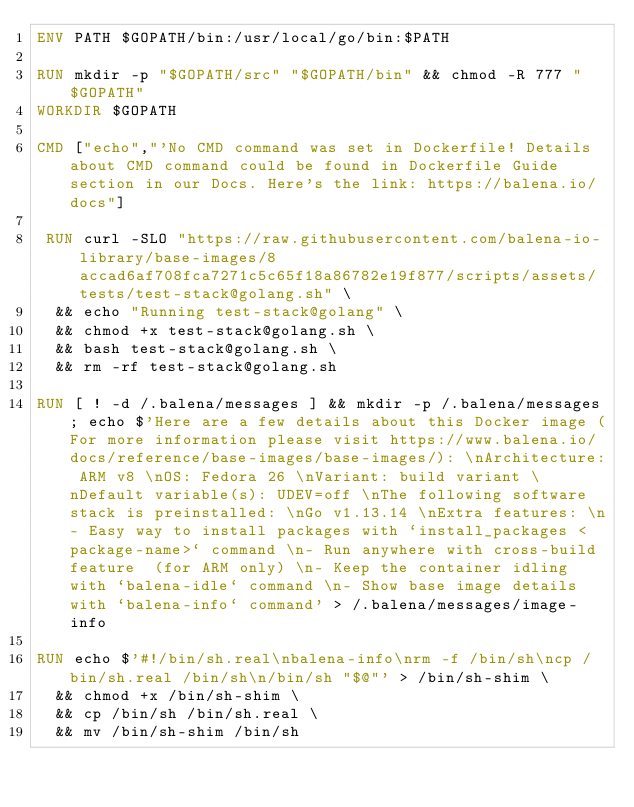Convert code to text. <code><loc_0><loc_0><loc_500><loc_500><_Dockerfile_>ENV PATH $GOPATH/bin:/usr/local/go/bin:$PATH

RUN mkdir -p "$GOPATH/src" "$GOPATH/bin" && chmod -R 777 "$GOPATH"
WORKDIR $GOPATH

CMD ["echo","'No CMD command was set in Dockerfile! Details about CMD command could be found in Dockerfile Guide section in our Docs. Here's the link: https://balena.io/docs"]

 RUN curl -SLO "https://raw.githubusercontent.com/balena-io-library/base-images/8accad6af708fca7271c5c65f18a86782e19f877/scripts/assets/tests/test-stack@golang.sh" \
  && echo "Running test-stack@golang" \
  && chmod +x test-stack@golang.sh \
  && bash test-stack@golang.sh \
  && rm -rf test-stack@golang.sh 

RUN [ ! -d /.balena/messages ] && mkdir -p /.balena/messages; echo $'Here are a few details about this Docker image (For more information please visit https://www.balena.io/docs/reference/base-images/base-images/): \nArchitecture: ARM v8 \nOS: Fedora 26 \nVariant: build variant \nDefault variable(s): UDEV=off \nThe following software stack is preinstalled: \nGo v1.13.14 \nExtra features: \n- Easy way to install packages with `install_packages <package-name>` command \n- Run anywhere with cross-build feature  (for ARM only) \n- Keep the container idling with `balena-idle` command \n- Show base image details with `balena-info` command' > /.balena/messages/image-info

RUN echo $'#!/bin/sh.real\nbalena-info\nrm -f /bin/sh\ncp /bin/sh.real /bin/sh\n/bin/sh "$@"' > /bin/sh-shim \
	&& chmod +x /bin/sh-shim \
	&& cp /bin/sh /bin/sh.real \
	&& mv /bin/sh-shim /bin/sh</code> 